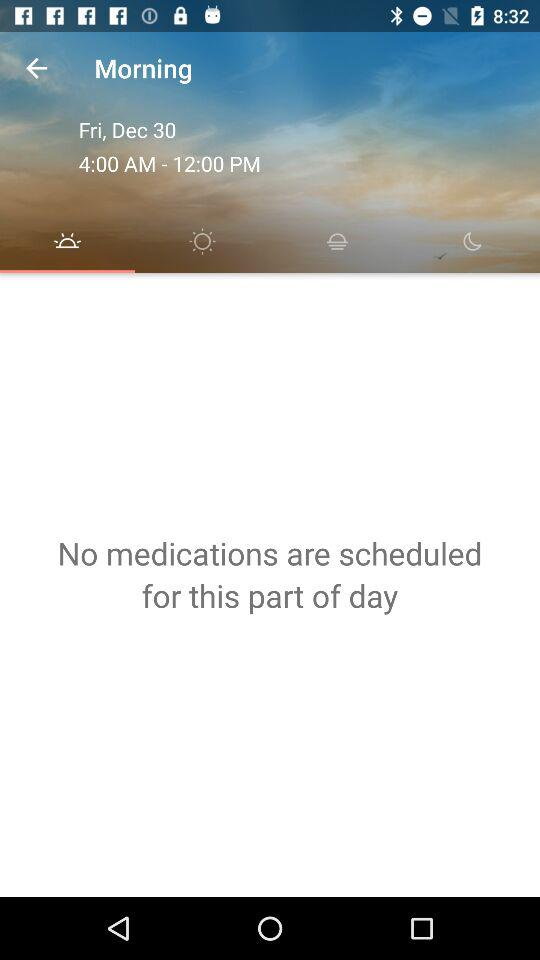What is the mentioned time range? The mentioned time range is 4:00 a.m. to 12:00 p.m. 